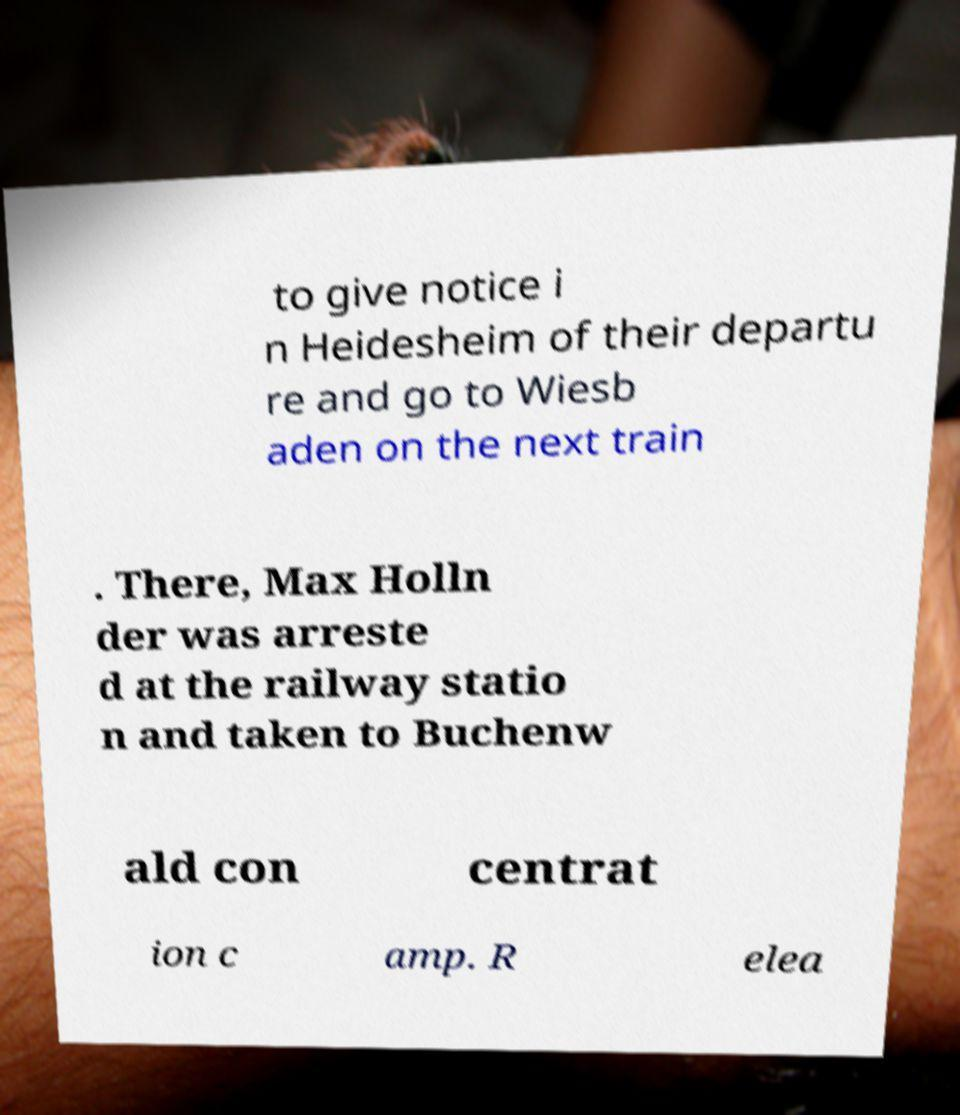I need the written content from this picture converted into text. Can you do that? to give notice i n Heidesheim of their departu re and go to Wiesb aden on the next train . There, Max Holln der was arreste d at the railway statio n and taken to Buchenw ald con centrat ion c amp. R elea 